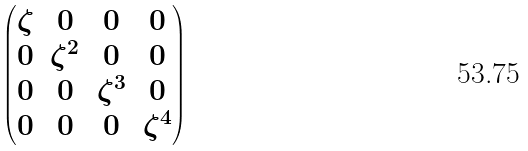<formula> <loc_0><loc_0><loc_500><loc_500>\begin{pmatrix} \zeta & 0 & 0 & 0 \\ 0 & \zeta ^ { 2 } & 0 & 0 \\ 0 & 0 & \zeta ^ { 3 } & 0 \\ 0 & 0 & 0 & \zeta ^ { 4 } \end{pmatrix}</formula> 